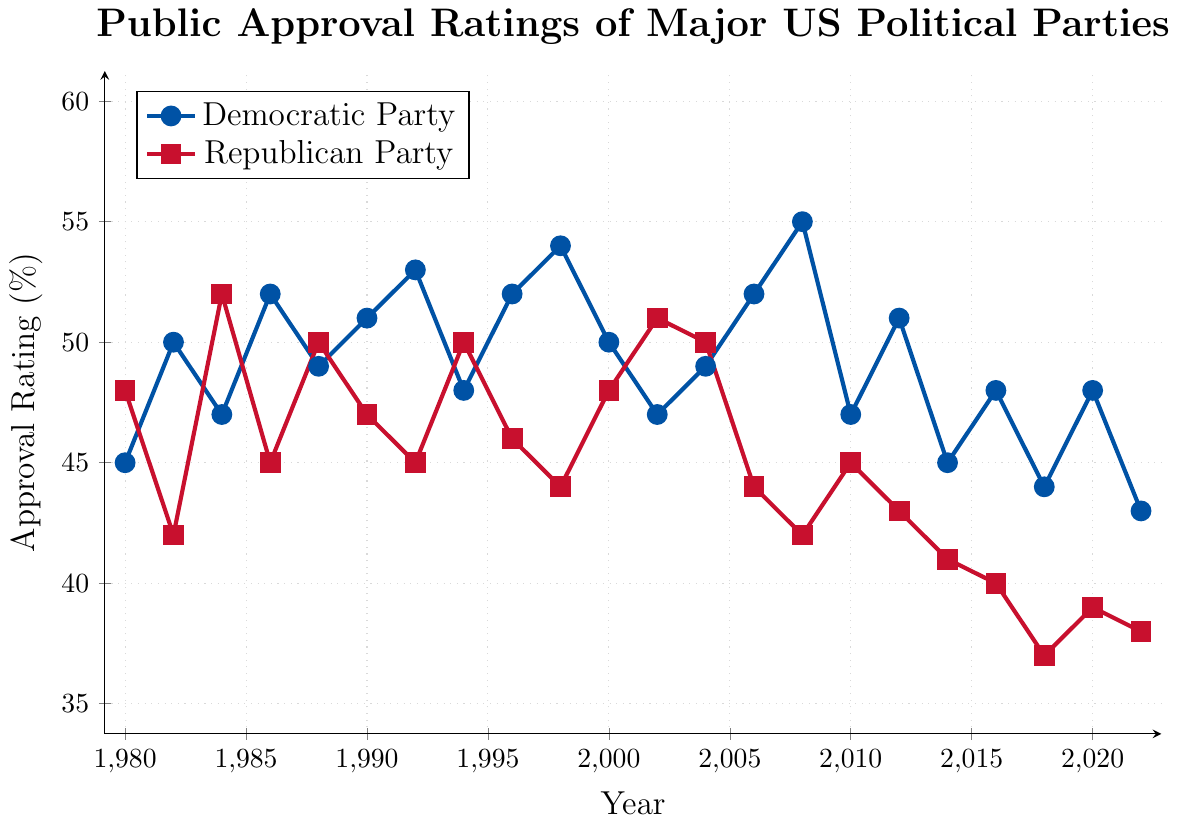How many years did the Democratic Party have an approval rating of 50% or more? Count the years in the graph where the Democratic Party's approval rating is 50% or higher. These years are 1982, 1986, 1988, 1990, 1992, 1996, 1998, 2000, 2004, 2006, 2008, 2012.
Answer: 12 Which year had the highest approval rating for the Republican Party? Identify the year where the line representing the Republican Party reaches its highest point on the y-axis, which corresponds to the approval rating. The peak appears in 1984.
Answer: 1984 In which year did both parties have the same approval rating, and what was it? Look for the point where the lines of both parties intersect. In 1988, both the Democratic and Republican Parties had an approval rating of 50%.
Answer: 1988, 50% What is the difference in the approval rating between the Democratic and Republican Parties in 2018? Subtract the Republican Party's approval rating from the Democratic Party's approval rating for 2018. The values are 44% for Democratic and 37% for Republican, resulting in a difference of 7%.
Answer: 7% Identify the time periods where the Democratic Party had a consistently higher approval rating than the Republican Party. Look for intervals where the blue line remains above the red line. These periods are 1982-1983, 1986-1987, 1990-1993, 1996-1997, 1998-2001, 2006-2009, 2012-2015, and 2016-2022.
Answer: Multiple periods Which party had a higher approval rating in 2002 and by how much? Compare the data points for both parties in 2002. The Republican Party had an approval rating of 51%, while the Democratic Party had 47%. The Republican Party had a higher rating by 4%.
Answer: Republican Party, 4% What is the overall trend in the approval rating of the Republican Party from 1980 to 2022? Observe the changes in the Republican Party's line from the beginning to the end of the timeline. The Republican Party's approval rating shows a general downward trend from around 48% in 1980 to about 38% in 2022.
Answer: Downward trend How much did the Democratic Party’s approval rating change from 2008 to 2010? Find the data points for the Democratic Party in 2008 and 2010 and calculate the difference. The approval rating was 55% in 2008 and 47% in 2010, showing a decrease of 8%.
Answer: 8% During which years did the Democratic Party experience a decrease in approval rating? Identify the years where the blue line slopes downward. These years are 1984, 1994, 2002, 2010, 2014, and 2018.
Answer: Multiple periods In what year was the gap between the approval ratings of the two parties the highest, and what was the gap? Calculate the absolute difference between the two parties' approval ratings for each year, and identify the year with the maximum gap. The largest gap is in 2008, with Democratic at 55% and Republican at 42%, resulting in a gap of 13 percentage points.
Answer: 2008, 13 